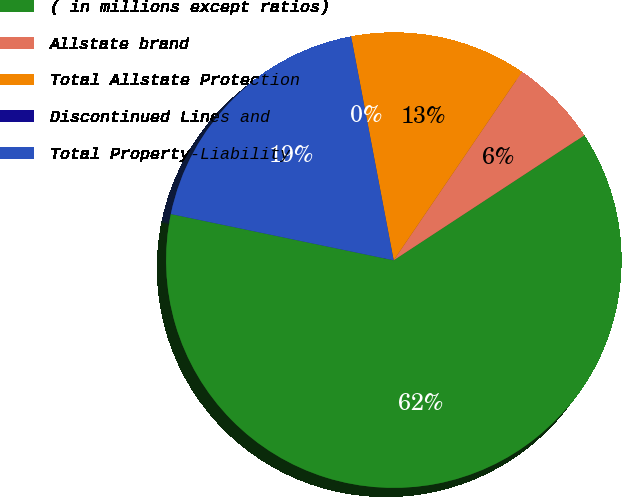<chart> <loc_0><loc_0><loc_500><loc_500><pie_chart><fcel>( in millions except ratios)<fcel>Allstate brand<fcel>Total Allstate Protection<fcel>Discontinued Lines and<fcel>Total Property-Liability<nl><fcel>62.49%<fcel>6.25%<fcel>12.5%<fcel>0.0%<fcel>18.75%<nl></chart> 